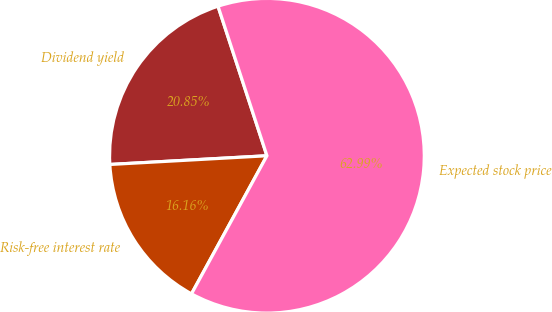Convert chart to OTSL. <chart><loc_0><loc_0><loc_500><loc_500><pie_chart><fcel>Dividend yield<fcel>Risk-free interest rate<fcel>Expected stock price<nl><fcel>20.85%<fcel>16.16%<fcel>62.99%<nl></chart> 